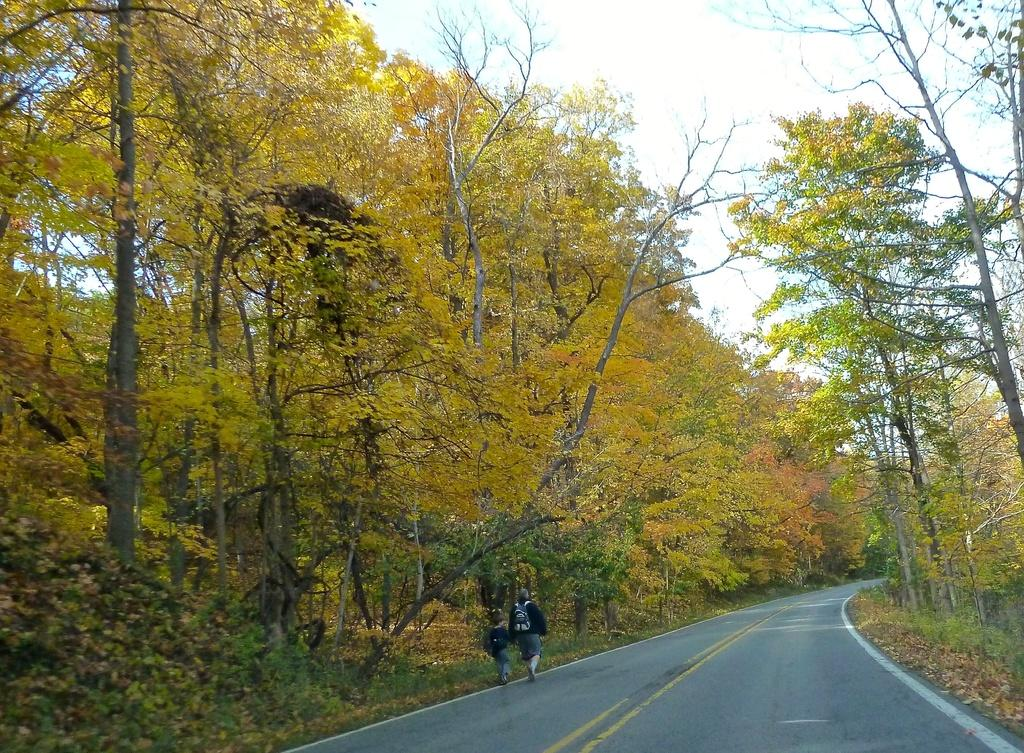How many people are in the image? There are two persons in the image. What are the persons doing in the image? The persons are walking on the road. What are the persons carrying while walking on the road? The persons are carrying bags on their shoulders. What can be seen on either side of the road in the image? There are trees on either side of the road. What is visible in the sky in the background of the image? There are clouds in the sky in the background of the image. What type of carriage can be seen in the image? There is no carriage present in the image. How many girls are visible in the image? The image does not show any girls; it features two persons who are likely adults. 